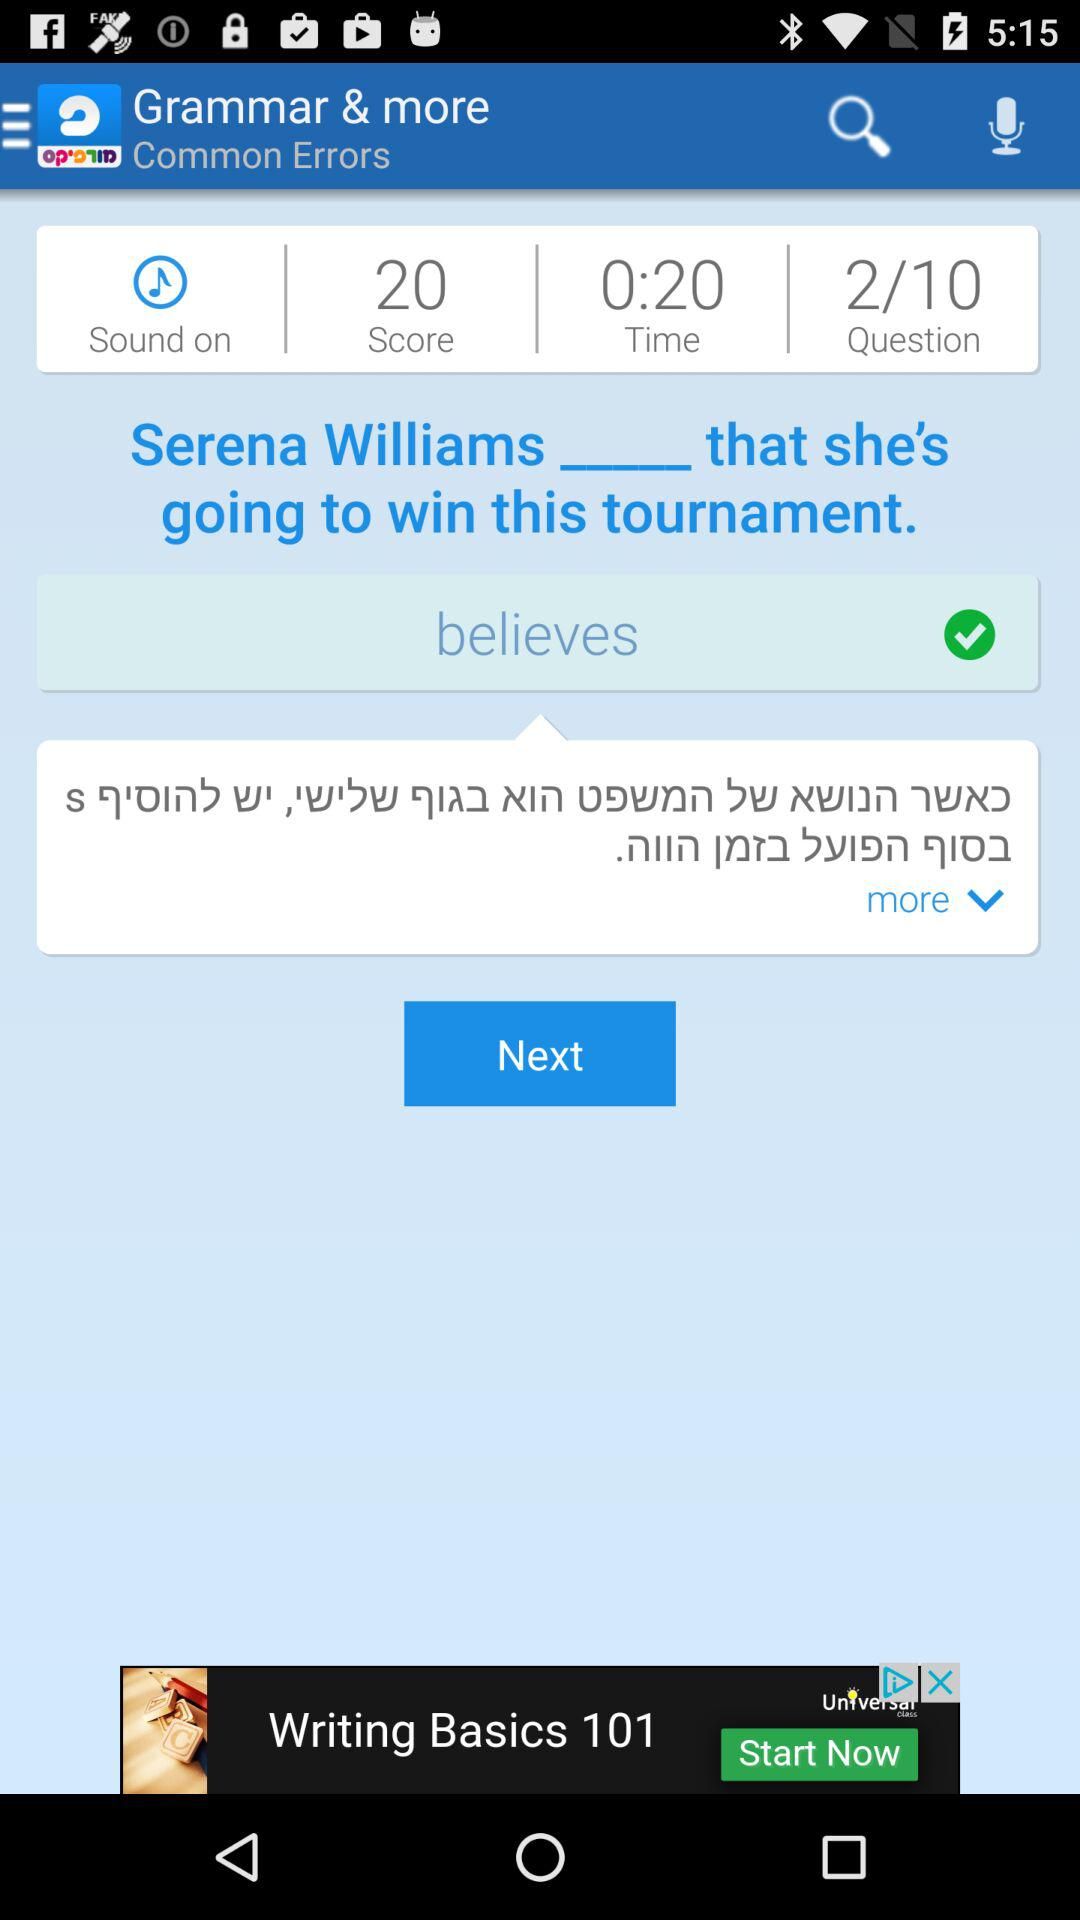How many questions are there in this? There are 10 questions. 